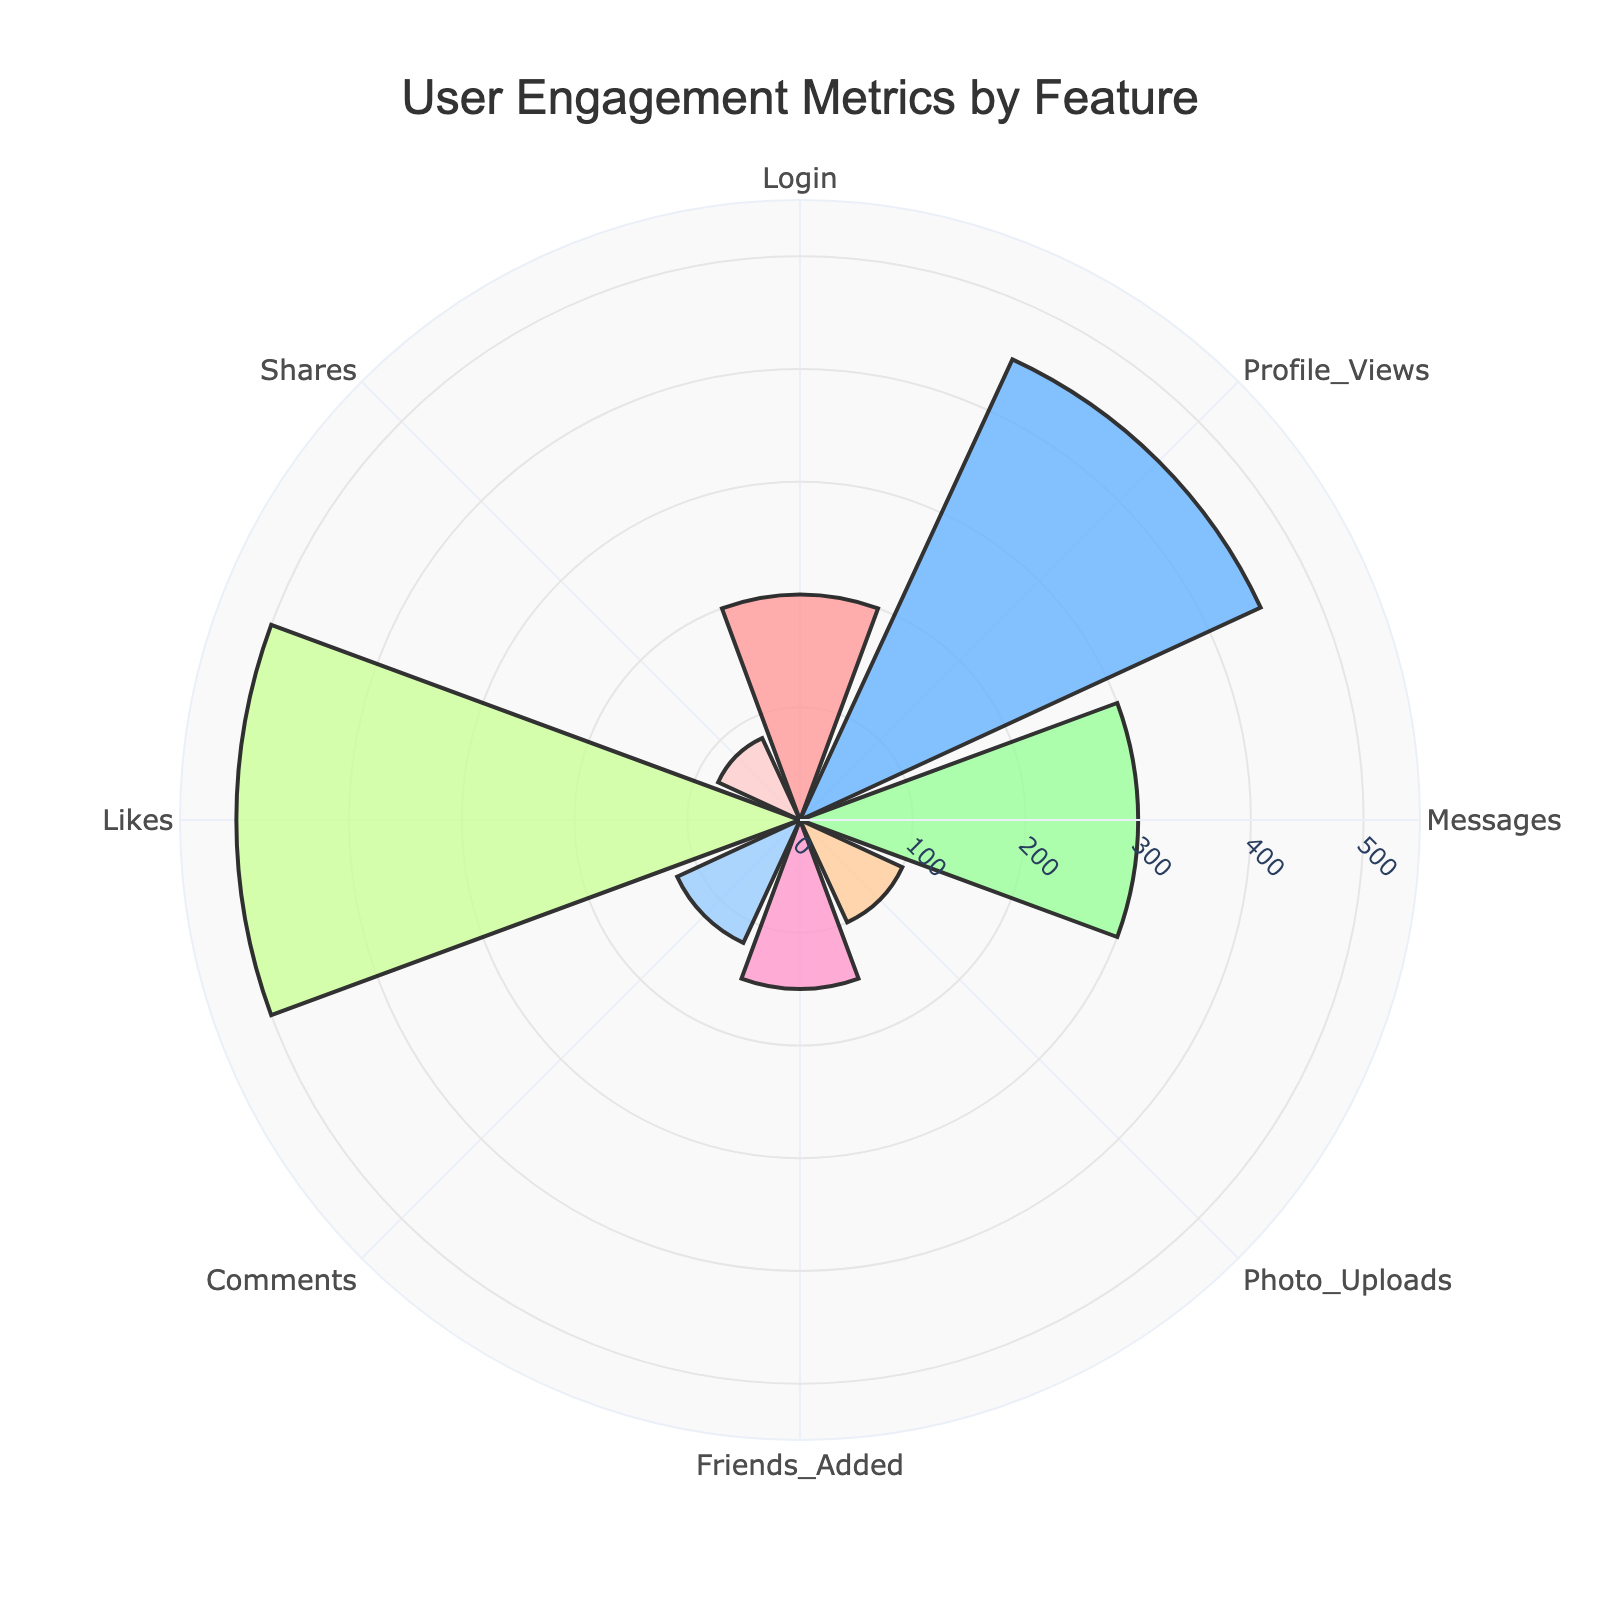How many features are displayed in the polar area chart? Count the unique features listed along the angular axis
Answer: 8 What is the title of the polar area chart? Read the text positioned at the top center of the polar chart
Answer: User Engagement Metrics by Feature Which feature has the highest engagement time? Identify the bar that extends the furthest from the center
Answer: Likes What are the colors used for the segments in the plot? Observe and list the eight different colors of the segments
Answer: Shades of pink, blue, green, orange, and red What is the engagement time for the 'Messages' feature? Locate the 'Messages' feature on the angular axis, then read the corresponding bar length
Answer: 300 What is the total engagement time for 'Photo Uploads', 'Friends Added', and 'Comments'? Locate each feature, read their values, and sum them: 100 + 150 + 120
Answer: 370 Which feature has the lowest engagement time, and what is that time? Identify the shortest bar and read the label and value
Answer: Shares, 80 What is the average engagement time across all features? Sum all engagement times and divide by the number of features: (200 + 450 + 300 + 100 + 150 + 120 + 500 + 80) / 8
Answer: 237.5 Is the engagement time for 'Login' and 'Profile Views' combined more than 'Likes'? Sum the values for 'Login' and 'Profile Views': 200 + 450 = 650, then compare it with 'Likes': 500
Answer: Yes Are there any features with an engagement time of 100 hours or less? Identify bars with a value of 100 or less
Answer: Yes, Photo Uploads and Shares 